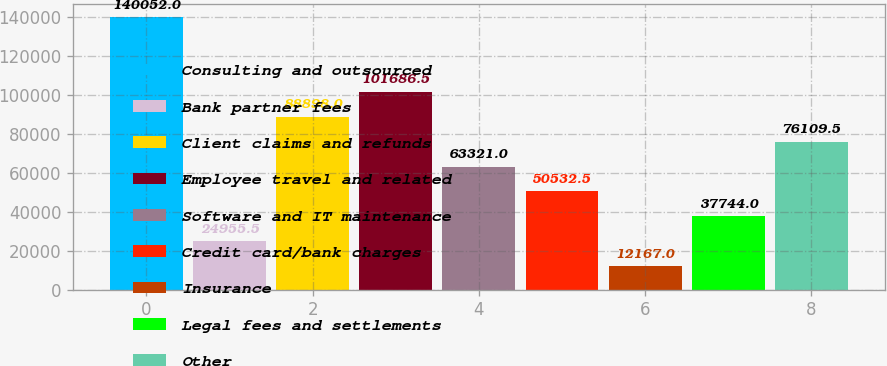Convert chart. <chart><loc_0><loc_0><loc_500><loc_500><bar_chart><fcel>Consulting and outsourced<fcel>Bank partner fees<fcel>Client claims and refunds<fcel>Employee travel and related<fcel>Software and IT maintenance<fcel>Credit card/bank charges<fcel>Insurance<fcel>Legal fees and settlements<fcel>Other<nl><fcel>140052<fcel>24955.5<fcel>88898<fcel>101686<fcel>63321<fcel>50532.5<fcel>12167<fcel>37744<fcel>76109.5<nl></chart> 